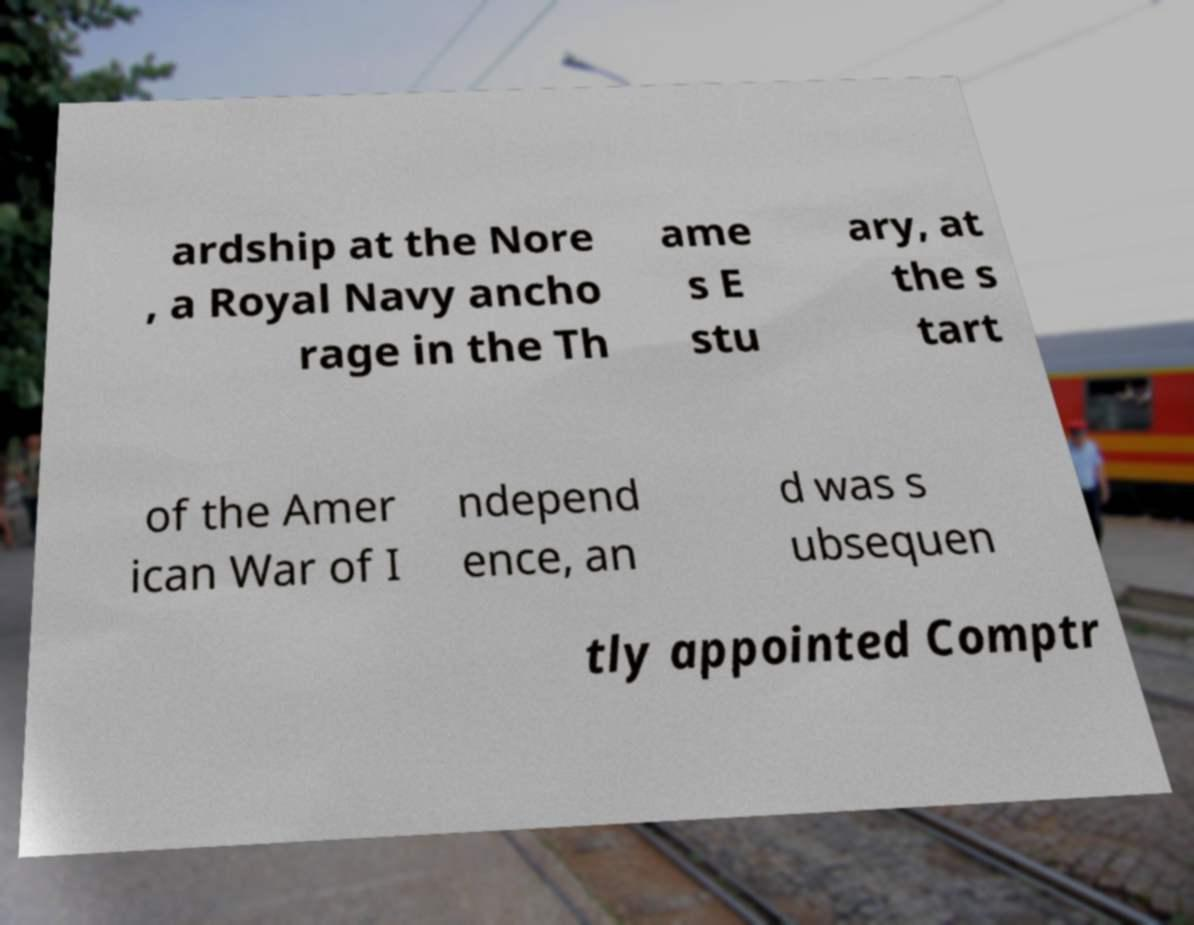Please identify and transcribe the text found in this image. ardship at the Nore , a Royal Navy ancho rage in the Th ame s E stu ary, at the s tart of the Amer ican War of I ndepend ence, an d was s ubsequen tly appointed Comptr 